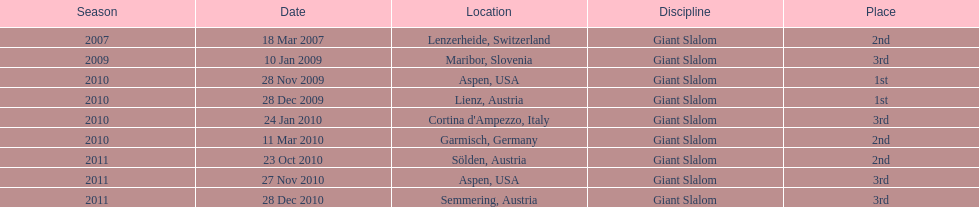In the list provided, what is the sum of her 2nd place finishes? 3. 